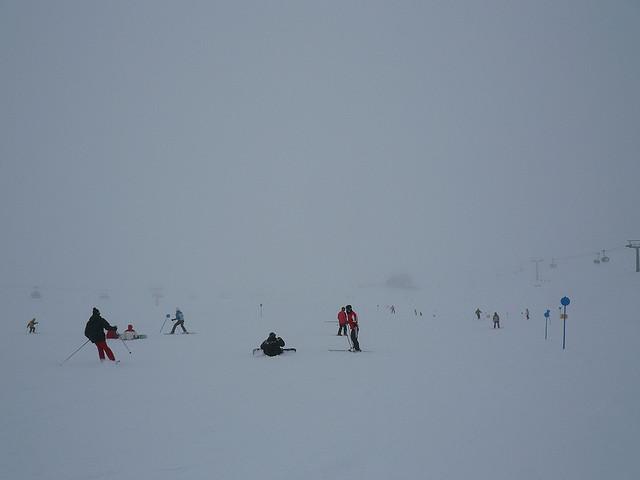Is the water nearby?
Be succinct. No. How many people in the shot?
Quick response, please. 9. What direction is the skier leaning?
Answer briefly. Left. Is there a bird in the photo?
Quick response, please. No. Why is the skier wearing a helmet?
Answer briefly. Protection. Is there a kite in the sky?
Be succinct. No. Is the sky blue?
Short answer required. No. Is this person snowboarding in a competition?
Short answer required. No. How many skiers are there?
Be succinct. Several. Is the skier sitting?
Give a very brief answer. Yes. Is it snowing?
Write a very short answer. Yes. Is it foggy?
Keep it brief. Yes. What type of creatures are in this image?
Short answer required. Humans. 